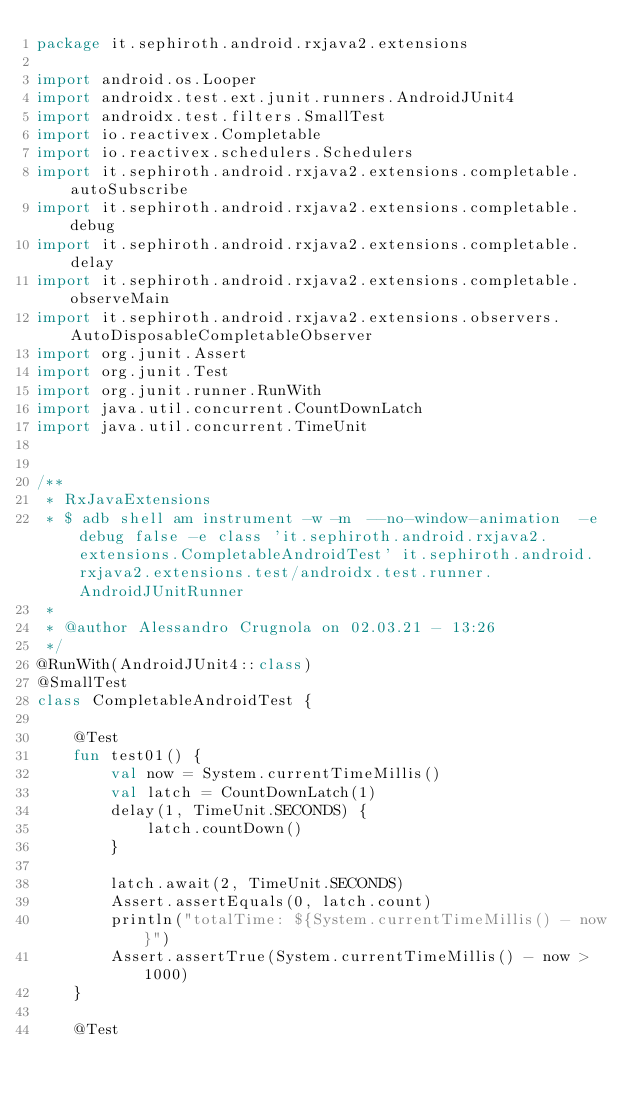<code> <loc_0><loc_0><loc_500><loc_500><_Kotlin_>package it.sephiroth.android.rxjava2.extensions

import android.os.Looper
import androidx.test.ext.junit.runners.AndroidJUnit4
import androidx.test.filters.SmallTest
import io.reactivex.Completable
import io.reactivex.schedulers.Schedulers
import it.sephiroth.android.rxjava2.extensions.completable.autoSubscribe
import it.sephiroth.android.rxjava2.extensions.completable.debug
import it.sephiroth.android.rxjava2.extensions.completable.delay
import it.sephiroth.android.rxjava2.extensions.completable.observeMain
import it.sephiroth.android.rxjava2.extensions.observers.AutoDisposableCompletableObserver
import org.junit.Assert
import org.junit.Test
import org.junit.runner.RunWith
import java.util.concurrent.CountDownLatch
import java.util.concurrent.TimeUnit


/**
 * RxJavaExtensions
 * $ adb shell am instrument -w -m  --no-window-animation  -e debug false -e class 'it.sephiroth.android.rxjava2.extensions.CompletableAndroidTest' it.sephiroth.android.rxjava2.extensions.test/androidx.test.runner.AndroidJUnitRunner
 *
 * @author Alessandro Crugnola on 02.03.21 - 13:26
 */
@RunWith(AndroidJUnit4::class)
@SmallTest
class CompletableAndroidTest {

    @Test
    fun test01() {
        val now = System.currentTimeMillis()
        val latch = CountDownLatch(1)
        delay(1, TimeUnit.SECONDS) {
            latch.countDown()
        }

        latch.await(2, TimeUnit.SECONDS)
        Assert.assertEquals(0, latch.count)
        println("totalTime: ${System.currentTimeMillis() - now}")
        Assert.assertTrue(System.currentTimeMillis() - now > 1000)
    }

    @Test</code> 